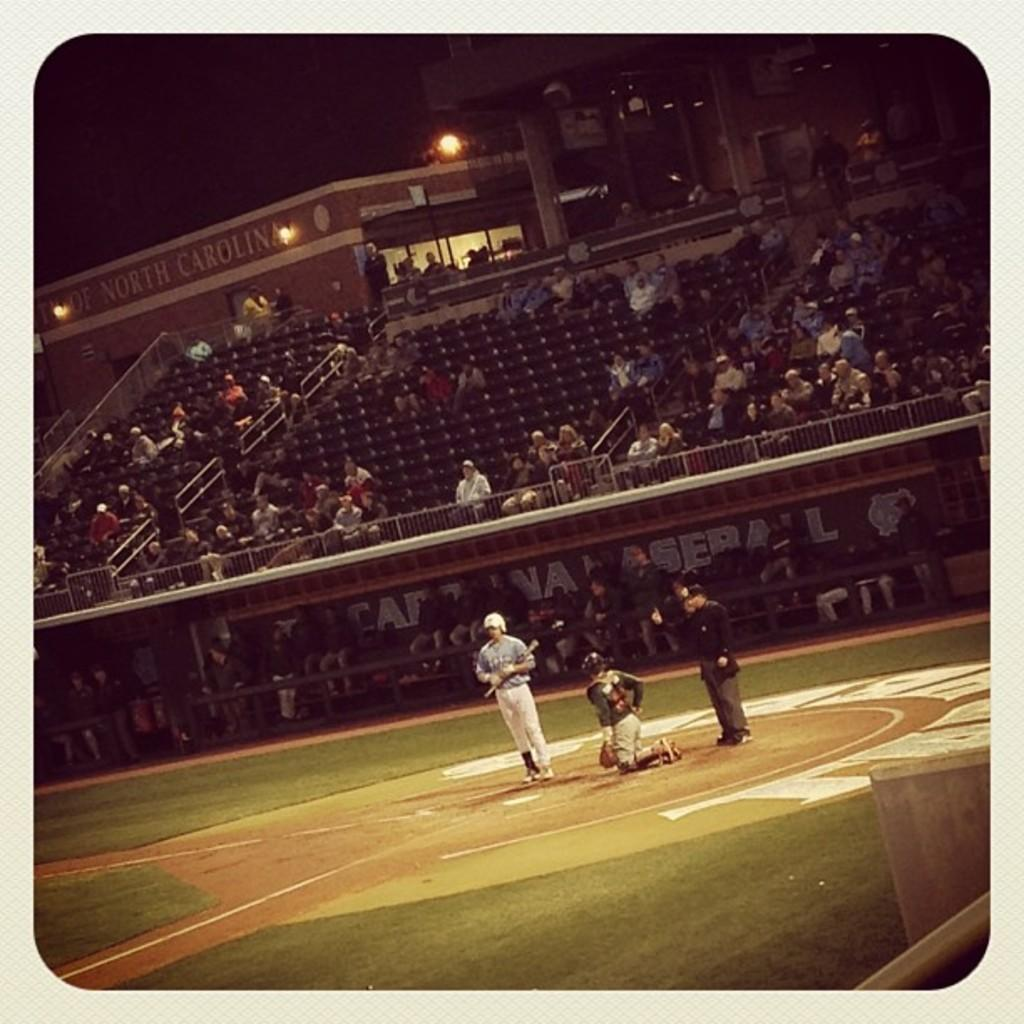Provide a one-sentence caption for the provided image. A few fans are in the stands of a baseball game at the University of North Carolina. 